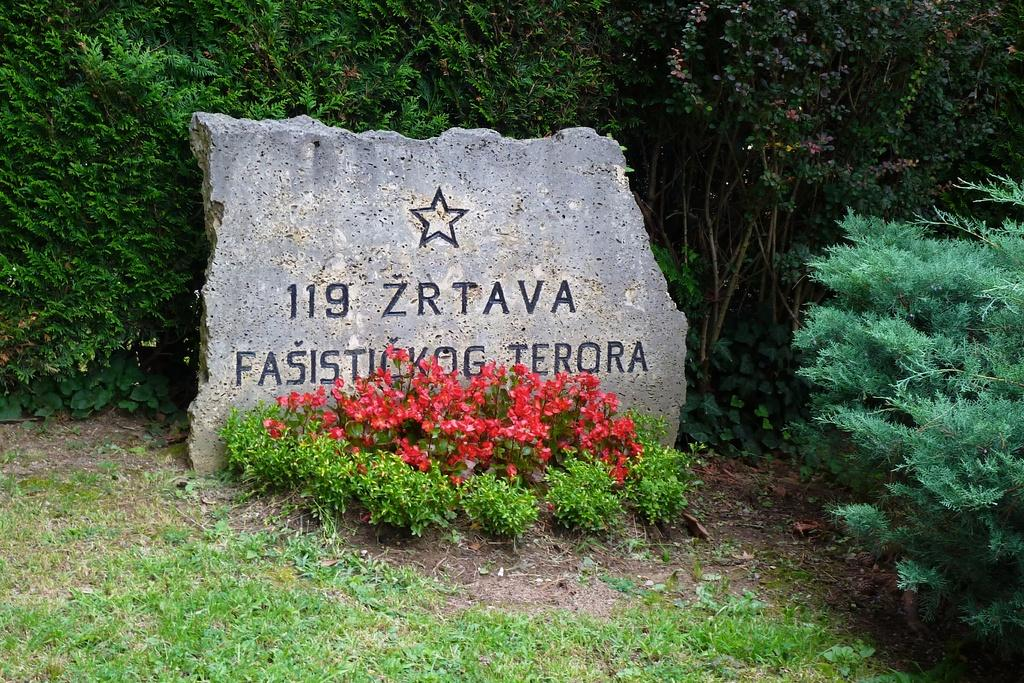What is carved on the stone in the image? There are numbers and letters carved on a stone in the image. What is in front of the stone? There is grass, plants, and flowers in front of the stone. What can be seen in the background of the image? There are trees in the background of the image. What type of lettuce is growing under the stone in the image? There is no lettuce present in the image; it features a stone with numbers and letters, surrounded by grass, plants, and flowers. 